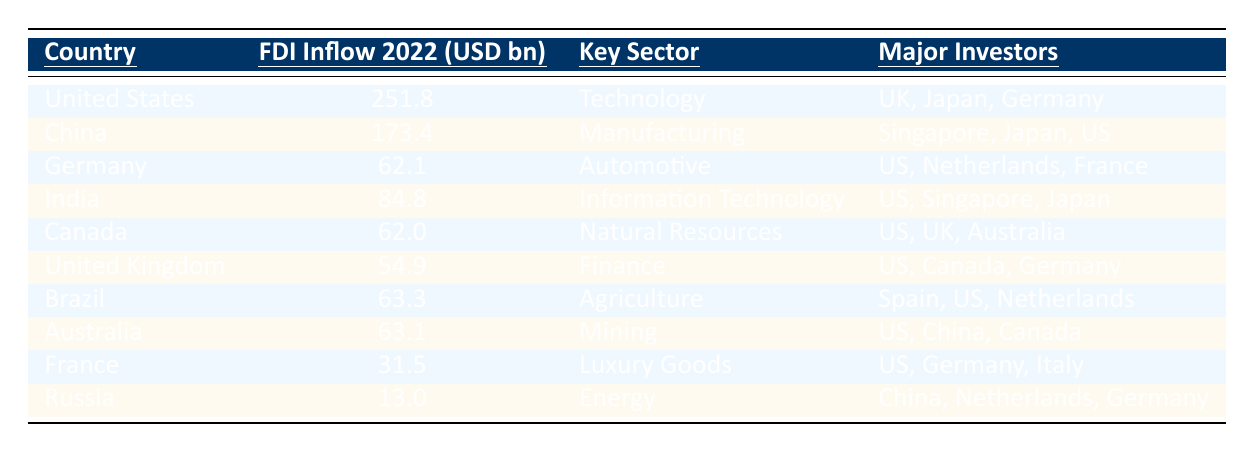What is the FDI inflow of the United States in 2022? The table indicates that the FDI inflow for the United States in 2022 is listed in the second column as 251.8 billion USD.
Answer: 251.8 billion USD Which country received the highest FDI inflow in 2022? By comparing the values in the FDI inflow column, the highest amount is 251.8 billion USD for the United States, which is greater than all other countries listed.
Answer: United States What is the FDI inflow of China, and which sector does it belong to? Referring to the table, China's FDI inflow in 2022 is 173.4 billion USD, and it belongs to the manufacturing sector as indicated in the respective columns.
Answer: 173.4 billion USD, Manufacturing What is the total FDI inflow for India and Brazil combined in 2022? To find the total, we add the FDI inflows of India (84.8 billion USD) and Brazil (63.3 billion USD): 84.8 + 63.3 = 148.1 billion USD.
Answer: 148.1 billion USD Which country had the lowest FDI inflow in 2022? The lowest value in the FDI inflow column belongs to Russia, with an inflow of 13.0 billion USD, making it the country with the lowest inflow.
Answer: Russia Are the major investors for Germany one of the countries listed? The table shows that major investors for Germany are the United States, Netherlands, and France. All these countries are listed in the table.
Answer: Yes How much higher is the FDI inflow of the United States compared to that of Russia? Subtracting Russia's FDI inflow (13.0 billion USD) from the United States' inflow (251.8 billion USD), we have 251.8 - 13.0 = 238.8 billion USD.
Answer: 238.8 billion USD What is the average FDI inflow of the top three countries in 2022? The top three countries by FDI inflow are the United States (251.8 billion USD), China (173.4 billion USD), and India (84.8 billion USD). Their sum is 251.8 + 173.4 + 84.8 = 510 billion USD. The average is 510/3 = 170 billion USD.
Answer: 170 billion USD Which sector attracted the most FDI inflow in 2022? The sector with the highest inflow is Technology linked with the United States at 251.8 billion USD, which is greater than any other sector's inflow amount.
Answer: Technology Which countries are major investors in Canada's FDI? The table indicates that the major investors for Canada are the United States, United Kingdom, and Australia, which are all listed in the table.
Answer: United States, United Kingdom, Australia 